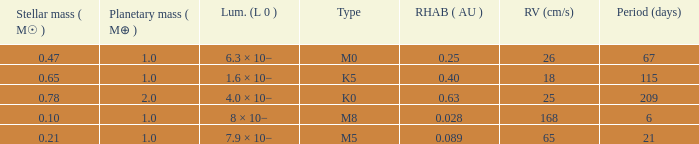What is the total stellar mass of the type m0? 0.47. 